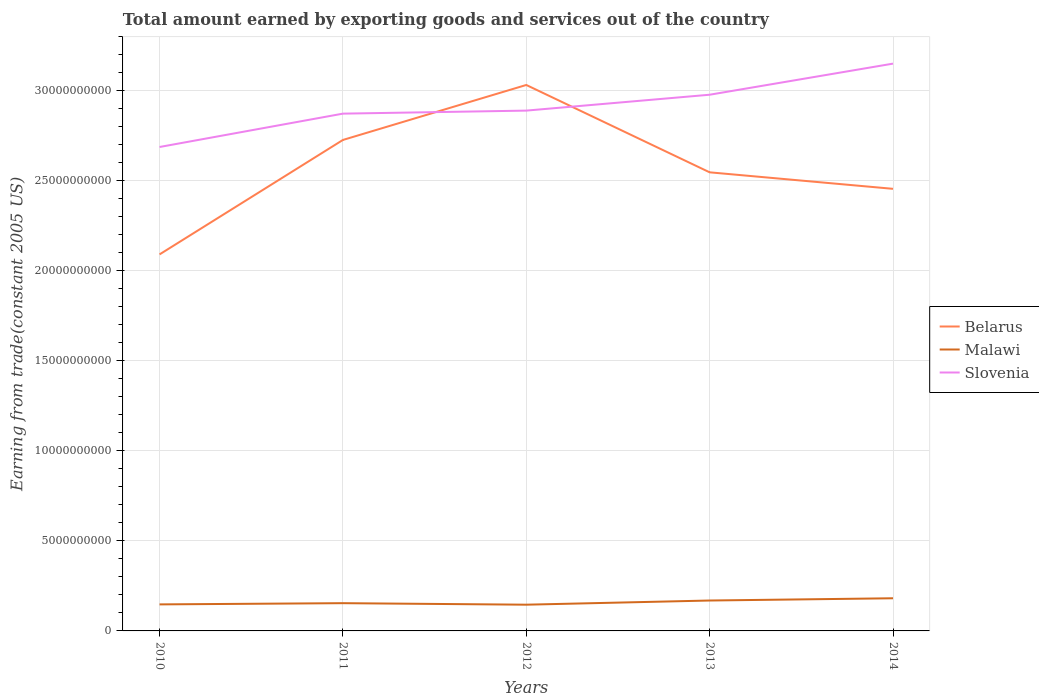How many different coloured lines are there?
Keep it short and to the point. 3. Does the line corresponding to Slovenia intersect with the line corresponding to Malawi?
Your answer should be very brief. No. Is the number of lines equal to the number of legend labels?
Your answer should be compact. Yes. Across all years, what is the maximum total amount earned by exporting goods and services in Belarus?
Ensure brevity in your answer.  2.09e+1. What is the total total amount earned by exporting goods and services in Slovenia in the graph?
Provide a short and direct response. -2.61e+09. What is the difference between the highest and the second highest total amount earned by exporting goods and services in Malawi?
Ensure brevity in your answer.  3.57e+08. How many years are there in the graph?
Offer a very short reply. 5. What is the difference between two consecutive major ticks on the Y-axis?
Offer a very short reply. 5.00e+09. Are the values on the major ticks of Y-axis written in scientific E-notation?
Keep it short and to the point. No. Where does the legend appear in the graph?
Make the answer very short. Center right. How many legend labels are there?
Offer a terse response. 3. What is the title of the graph?
Provide a succinct answer. Total amount earned by exporting goods and services out of the country. What is the label or title of the Y-axis?
Ensure brevity in your answer.  Earning from trade(constant 2005 US). What is the Earning from trade(constant 2005 US) in Belarus in 2010?
Your answer should be compact. 2.09e+1. What is the Earning from trade(constant 2005 US) in Malawi in 2010?
Give a very brief answer. 1.47e+09. What is the Earning from trade(constant 2005 US) of Slovenia in 2010?
Offer a terse response. 2.69e+1. What is the Earning from trade(constant 2005 US) of Belarus in 2011?
Provide a succinct answer. 2.73e+1. What is the Earning from trade(constant 2005 US) in Malawi in 2011?
Your answer should be compact. 1.54e+09. What is the Earning from trade(constant 2005 US) in Slovenia in 2011?
Provide a short and direct response. 2.87e+1. What is the Earning from trade(constant 2005 US) in Belarus in 2012?
Provide a succinct answer. 3.03e+1. What is the Earning from trade(constant 2005 US) in Malawi in 2012?
Your answer should be compact. 1.46e+09. What is the Earning from trade(constant 2005 US) of Slovenia in 2012?
Provide a short and direct response. 2.89e+1. What is the Earning from trade(constant 2005 US) in Belarus in 2013?
Your response must be concise. 2.55e+1. What is the Earning from trade(constant 2005 US) of Malawi in 2013?
Your response must be concise. 1.69e+09. What is the Earning from trade(constant 2005 US) of Slovenia in 2013?
Give a very brief answer. 2.98e+1. What is the Earning from trade(constant 2005 US) of Belarus in 2014?
Your response must be concise. 2.46e+1. What is the Earning from trade(constant 2005 US) in Malawi in 2014?
Make the answer very short. 1.81e+09. What is the Earning from trade(constant 2005 US) of Slovenia in 2014?
Offer a terse response. 3.15e+1. Across all years, what is the maximum Earning from trade(constant 2005 US) of Belarus?
Your response must be concise. 3.03e+1. Across all years, what is the maximum Earning from trade(constant 2005 US) of Malawi?
Keep it short and to the point. 1.81e+09. Across all years, what is the maximum Earning from trade(constant 2005 US) in Slovenia?
Ensure brevity in your answer.  3.15e+1. Across all years, what is the minimum Earning from trade(constant 2005 US) of Belarus?
Provide a short and direct response. 2.09e+1. Across all years, what is the minimum Earning from trade(constant 2005 US) in Malawi?
Your answer should be compact. 1.46e+09. Across all years, what is the minimum Earning from trade(constant 2005 US) in Slovenia?
Provide a short and direct response. 2.69e+1. What is the total Earning from trade(constant 2005 US) of Belarus in the graph?
Provide a short and direct response. 1.29e+11. What is the total Earning from trade(constant 2005 US) in Malawi in the graph?
Offer a very short reply. 7.97e+09. What is the total Earning from trade(constant 2005 US) of Slovenia in the graph?
Offer a very short reply. 1.46e+11. What is the difference between the Earning from trade(constant 2005 US) in Belarus in 2010 and that in 2011?
Provide a succinct answer. -6.36e+09. What is the difference between the Earning from trade(constant 2005 US) of Malawi in 2010 and that in 2011?
Offer a terse response. -6.82e+07. What is the difference between the Earning from trade(constant 2005 US) in Slovenia in 2010 and that in 2011?
Provide a short and direct response. -1.85e+09. What is the difference between the Earning from trade(constant 2005 US) of Belarus in 2010 and that in 2012?
Keep it short and to the point. -9.41e+09. What is the difference between the Earning from trade(constant 2005 US) in Malawi in 2010 and that in 2012?
Provide a short and direct response. 1.64e+07. What is the difference between the Earning from trade(constant 2005 US) of Slovenia in 2010 and that in 2012?
Your answer should be very brief. -2.02e+09. What is the difference between the Earning from trade(constant 2005 US) in Belarus in 2010 and that in 2013?
Keep it short and to the point. -4.56e+09. What is the difference between the Earning from trade(constant 2005 US) of Malawi in 2010 and that in 2013?
Offer a very short reply. -2.16e+08. What is the difference between the Earning from trade(constant 2005 US) in Slovenia in 2010 and that in 2013?
Give a very brief answer. -2.90e+09. What is the difference between the Earning from trade(constant 2005 US) of Belarus in 2010 and that in 2014?
Offer a very short reply. -3.64e+09. What is the difference between the Earning from trade(constant 2005 US) of Malawi in 2010 and that in 2014?
Provide a short and direct response. -3.41e+08. What is the difference between the Earning from trade(constant 2005 US) in Slovenia in 2010 and that in 2014?
Give a very brief answer. -4.63e+09. What is the difference between the Earning from trade(constant 2005 US) of Belarus in 2011 and that in 2012?
Ensure brevity in your answer.  -3.05e+09. What is the difference between the Earning from trade(constant 2005 US) of Malawi in 2011 and that in 2012?
Your answer should be very brief. 8.46e+07. What is the difference between the Earning from trade(constant 2005 US) of Slovenia in 2011 and that in 2012?
Your answer should be very brief. -1.68e+08. What is the difference between the Earning from trade(constant 2005 US) in Belarus in 2011 and that in 2013?
Provide a succinct answer. 1.80e+09. What is the difference between the Earning from trade(constant 2005 US) in Malawi in 2011 and that in 2013?
Offer a very short reply. -1.48e+08. What is the difference between the Earning from trade(constant 2005 US) in Slovenia in 2011 and that in 2013?
Provide a succinct answer. -1.05e+09. What is the difference between the Earning from trade(constant 2005 US) in Belarus in 2011 and that in 2014?
Provide a short and direct response. 2.71e+09. What is the difference between the Earning from trade(constant 2005 US) in Malawi in 2011 and that in 2014?
Offer a terse response. -2.72e+08. What is the difference between the Earning from trade(constant 2005 US) of Slovenia in 2011 and that in 2014?
Your answer should be compact. -2.78e+09. What is the difference between the Earning from trade(constant 2005 US) in Belarus in 2012 and that in 2013?
Provide a short and direct response. 4.85e+09. What is the difference between the Earning from trade(constant 2005 US) in Malawi in 2012 and that in 2013?
Offer a very short reply. -2.32e+08. What is the difference between the Earning from trade(constant 2005 US) in Slovenia in 2012 and that in 2013?
Your answer should be compact. -8.82e+08. What is the difference between the Earning from trade(constant 2005 US) of Belarus in 2012 and that in 2014?
Your answer should be very brief. 5.77e+09. What is the difference between the Earning from trade(constant 2005 US) in Malawi in 2012 and that in 2014?
Your answer should be compact. -3.57e+08. What is the difference between the Earning from trade(constant 2005 US) of Slovenia in 2012 and that in 2014?
Your answer should be very brief. -2.61e+09. What is the difference between the Earning from trade(constant 2005 US) in Belarus in 2013 and that in 2014?
Provide a short and direct response. 9.17e+08. What is the difference between the Earning from trade(constant 2005 US) of Malawi in 2013 and that in 2014?
Offer a terse response. -1.25e+08. What is the difference between the Earning from trade(constant 2005 US) of Slovenia in 2013 and that in 2014?
Your answer should be very brief. -1.73e+09. What is the difference between the Earning from trade(constant 2005 US) in Belarus in 2010 and the Earning from trade(constant 2005 US) in Malawi in 2011?
Provide a short and direct response. 1.94e+1. What is the difference between the Earning from trade(constant 2005 US) of Belarus in 2010 and the Earning from trade(constant 2005 US) of Slovenia in 2011?
Offer a very short reply. -7.82e+09. What is the difference between the Earning from trade(constant 2005 US) in Malawi in 2010 and the Earning from trade(constant 2005 US) in Slovenia in 2011?
Offer a very short reply. -2.73e+1. What is the difference between the Earning from trade(constant 2005 US) in Belarus in 2010 and the Earning from trade(constant 2005 US) in Malawi in 2012?
Offer a very short reply. 1.95e+1. What is the difference between the Earning from trade(constant 2005 US) of Belarus in 2010 and the Earning from trade(constant 2005 US) of Slovenia in 2012?
Offer a very short reply. -7.99e+09. What is the difference between the Earning from trade(constant 2005 US) of Malawi in 2010 and the Earning from trade(constant 2005 US) of Slovenia in 2012?
Keep it short and to the point. -2.74e+1. What is the difference between the Earning from trade(constant 2005 US) in Belarus in 2010 and the Earning from trade(constant 2005 US) in Malawi in 2013?
Provide a short and direct response. 1.92e+1. What is the difference between the Earning from trade(constant 2005 US) in Belarus in 2010 and the Earning from trade(constant 2005 US) in Slovenia in 2013?
Give a very brief answer. -8.87e+09. What is the difference between the Earning from trade(constant 2005 US) in Malawi in 2010 and the Earning from trade(constant 2005 US) in Slovenia in 2013?
Give a very brief answer. -2.83e+1. What is the difference between the Earning from trade(constant 2005 US) of Belarus in 2010 and the Earning from trade(constant 2005 US) of Malawi in 2014?
Your response must be concise. 1.91e+1. What is the difference between the Earning from trade(constant 2005 US) in Belarus in 2010 and the Earning from trade(constant 2005 US) in Slovenia in 2014?
Your response must be concise. -1.06e+1. What is the difference between the Earning from trade(constant 2005 US) of Malawi in 2010 and the Earning from trade(constant 2005 US) of Slovenia in 2014?
Your response must be concise. -3.00e+1. What is the difference between the Earning from trade(constant 2005 US) of Belarus in 2011 and the Earning from trade(constant 2005 US) of Malawi in 2012?
Provide a succinct answer. 2.58e+1. What is the difference between the Earning from trade(constant 2005 US) in Belarus in 2011 and the Earning from trade(constant 2005 US) in Slovenia in 2012?
Keep it short and to the point. -1.63e+09. What is the difference between the Earning from trade(constant 2005 US) of Malawi in 2011 and the Earning from trade(constant 2005 US) of Slovenia in 2012?
Make the answer very short. -2.74e+1. What is the difference between the Earning from trade(constant 2005 US) in Belarus in 2011 and the Earning from trade(constant 2005 US) in Malawi in 2013?
Your response must be concise. 2.56e+1. What is the difference between the Earning from trade(constant 2005 US) in Belarus in 2011 and the Earning from trade(constant 2005 US) in Slovenia in 2013?
Keep it short and to the point. -2.51e+09. What is the difference between the Earning from trade(constant 2005 US) in Malawi in 2011 and the Earning from trade(constant 2005 US) in Slovenia in 2013?
Keep it short and to the point. -2.82e+1. What is the difference between the Earning from trade(constant 2005 US) in Belarus in 2011 and the Earning from trade(constant 2005 US) in Malawi in 2014?
Ensure brevity in your answer.  2.55e+1. What is the difference between the Earning from trade(constant 2005 US) of Belarus in 2011 and the Earning from trade(constant 2005 US) of Slovenia in 2014?
Ensure brevity in your answer.  -4.24e+09. What is the difference between the Earning from trade(constant 2005 US) of Malawi in 2011 and the Earning from trade(constant 2005 US) of Slovenia in 2014?
Provide a short and direct response. -3.00e+1. What is the difference between the Earning from trade(constant 2005 US) in Belarus in 2012 and the Earning from trade(constant 2005 US) in Malawi in 2013?
Provide a short and direct response. 2.86e+1. What is the difference between the Earning from trade(constant 2005 US) in Belarus in 2012 and the Earning from trade(constant 2005 US) in Slovenia in 2013?
Offer a very short reply. 5.42e+08. What is the difference between the Earning from trade(constant 2005 US) of Malawi in 2012 and the Earning from trade(constant 2005 US) of Slovenia in 2013?
Provide a short and direct response. -2.83e+1. What is the difference between the Earning from trade(constant 2005 US) in Belarus in 2012 and the Earning from trade(constant 2005 US) in Malawi in 2014?
Make the answer very short. 2.85e+1. What is the difference between the Earning from trade(constant 2005 US) in Belarus in 2012 and the Earning from trade(constant 2005 US) in Slovenia in 2014?
Offer a very short reply. -1.18e+09. What is the difference between the Earning from trade(constant 2005 US) of Malawi in 2012 and the Earning from trade(constant 2005 US) of Slovenia in 2014?
Offer a terse response. -3.00e+1. What is the difference between the Earning from trade(constant 2005 US) in Belarus in 2013 and the Earning from trade(constant 2005 US) in Malawi in 2014?
Keep it short and to the point. 2.37e+1. What is the difference between the Earning from trade(constant 2005 US) of Belarus in 2013 and the Earning from trade(constant 2005 US) of Slovenia in 2014?
Your answer should be compact. -6.04e+09. What is the difference between the Earning from trade(constant 2005 US) of Malawi in 2013 and the Earning from trade(constant 2005 US) of Slovenia in 2014?
Provide a short and direct response. -2.98e+1. What is the average Earning from trade(constant 2005 US) in Belarus per year?
Offer a terse response. 2.57e+1. What is the average Earning from trade(constant 2005 US) in Malawi per year?
Your response must be concise. 1.59e+09. What is the average Earning from trade(constant 2005 US) in Slovenia per year?
Offer a terse response. 2.92e+1. In the year 2010, what is the difference between the Earning from trade(constant 2005 US) of Belarus and Earning from trade(constant 2005 US) of Malawi?
Offer a very short reply. 1.94e+1. In the year 2010, what is the difference between the Earning from trade(constant 2005 US) of Belarus and Earning from trade(constant 2005 US) of Slovenia?
Make the answer very short. -5.96e+09. In the year 2010, what is the difference between the Earning from trade(constant 2005 US) in Malawi and Earning from trade(constant 2005 US) in Slovenia?
Your response must be concise. -2.54e+1. In the year 2011, what is the difference between the Earning from trade(constant 2005 US) in Belarus and Earning from trade(constant 2005 US) in Malawi?
Ensure brevity in your answer.  2.57e+1. In the year 2011, what is the difference between the Earning from trade(constant 2005 US) in Belarus and Earning from trade(constant 2005 US) in Slovenia?
Make the answer very short. -1.46e+09. In the year 2011, what is the difference between the Earning from trade(constant 2005 US) in Malawi and Earning from trade(constant 2005 US) in Slovenia?
Keep it short and to the point. -2.72e+1. In the year 2012, what is the difference between the Earning from trade(constant 2005 US) of Belarus and Earning from trade(constant 2005 US) of Malawi?
Your answer should be very brief. 2.89e+1. In the year 2012, what is the difference between the Earning from trade(constant 2005 US) in Belarus and Earning from trade(constant 2005 US) in Slovenia?
Keep it short and to the point. 1.42e+09. In the year 2012, what is the difference between the Earning from trade(constant 2005 US) of Malawi and Earning from trade(constant 2005 US) of Slovenia?
Offer a very short reply. -2.74e+1. In the year 2013, what is the difference between the Earning from trade(constant 2005 US) in Belarus and Earning from trade(constant 2005 US) in Malawi?
Offer a very short reply. 2.38e+1. In the year 2013, what is the difference between the Earning from trade(constant 2005 US) of Belarus and Earning from trade(constant 2005 US) of Slovenia?
Your response must be concise. -4.31e+09. In the year 2013, what is the difference between the Earning from trade(constant 2005 US) in Malawi and Earning from trade(constant 2005 US) in Slovenia?
Keep it short and to the point. -2.81e+1. In the year 2014, what is the difference between the Earning from trade(constant 2005 US) in Belarus and Earning from trade(constant 2005 US) in Malawi?
Your answer should be compact. 2.27e+1. In the year 2014, what is the difference between the Earning from trade(constant 2005 US) in Belarus and Earning from trade(constant 2005 US) in Slovenia?
Offer a terse response. -6.95e+09. In the year 2014, what is the difference between the Earning from trade(constant 2005 US) of Malawi and Earning from trade(constant 2005 US) of Slovenia?
Your answer should be very brief. -2.97e+1. What is the ratio of the Earning from trade(constant 2005 US) of Belarus in 2010 to that in 2011?
Your answer should be compact. 0.77. What is the ratio of the Earning from trade(constant 2005 US) in Malawi in 2010 to that in 2011?
Your response must be concise. 0.96. What is the ratio of the Earning from trade(constant 2005 US) in Slovenia in 2010 to that in 2011?
Your response must be concise. 0.94. What is the ratio of the Earning from trade(constant 2005 US) of Belarus in 2010 to that in 2012?
Keep it short and to the point. 0.69. What is the ratio of the Earning from trade(constant 2005 US) in Malawi in 2010 to that in 2012?
Your answer should be compact. 1.01. What is the ratio of the Earning from trade(constant 2005 US) in Slovenia in 2010 to that in 2012?
Give a very brief answer. 0.93. What is the ratio of the Earning from trade(constant 2005 US) of Belarus in 2010 to that in 2013?
Your answer should be very brief. 0.82. What is the ratio of the Earning from trade(constant 2005 US) in Malawi in 2010 to that in 2013?
Offer a terse response. 0.87. What is the ratio of the Earning from trade(constant 2005 US) in Slovenia in 2010 to that in 2013?
Make the answer very short. 0.9. What is the ratio of the Earning from trade(constant 2005 US) in Belarus in 2010 to that in 2014?
Keep it short and to the point. 0.85. What is the ratio of the Earning from trade(constant 2005 US) in Malawi in 2010 to that in 2014?
Offer a very short reply. 0.81. What is the ratio of the Earning from trade(constant 2005 US) in Slovenia in 2010 to that in 2014?
Your response must be concise. 0.85. What is the ratio of the Earning from trade(constant 2005 US) of Belarus in 2011 to that in 2012?
Give a very brief answer. 0.9. What is the ratio of the Earning from trade(constant 2005 US) in Malawi in 2011 to that in 2012?
Ensure brevity in your answer.  1.06. What is the ratio of the Earning from trade(constant 2005 US) of Belarus in 2011 to that in 2013?
Make the answer very short. 1.07. What is the ratio of the Earning from trade(constant 2005 US) of Malawi in 2011 to that in 2013?
Offer a terse response. 0.91. What is the ratio of the Earning from trade(constant 2005 US) of Slovenia in 2011 to that in 2013?
Give a very brief answer. 0.96. What is the ratio of the Earning from trade(constant 2005 US) of Belarus in 2011 to that in 2014?
Provide a succinct answer. 1.11. What is the ratio of the Earning from trade(constant 2005 US) of Malawi in 2011 to that in 2014?
Your answer should be compact. 0.85. What is the ratio of the Earning from trade(constant 2005 US) of Slovenia in 2011 to that in 2014?
Ensure brevity in your answer.  0.91. What is the ratio of the Earning from trade(constant 2005 US) in Belarus in 2012 to that in 2013?
Your answer should be very brief. 1.19. What is the ratio of the Earning from trade(constant 2005 US) in Malawi in 2012 to that in 2013?
Your response must be concise. 0.86. What is the ratio of the Earning from trade(constant 2005 US) in Slovenia in 2012 to that in 2013?
Your answer should be compact. 0.97. What is the ratio of the Earning from trade(constant 2005 US) of Belarus in 2012 to that in 2014?
Provide a short and direct response. 1.23. What is the ratio of the Earning from trade(constant 2005 US) of Malawi in 2012 to that in 2014?
Keep it short and to the point. 0.8. What is the ratio of the Earning from trade(constant 2005 US) in Slovenia in 2012 to that in 2014?
Provide a short and direct response. 0.92. What is the ratio of the Earning from trade(constant 2005 US) in Belarus in 2013 to that in 2014?
Offer a very short reply. 1.04. What is the ratio of the Earning from trade(constant 2005 US) in Malawi in 2013 to that in 2014?
Your answer should be compact. 0.93. What is the ratio of the Earning from trade(constant 2005 US) in Slovenia in 2013 to that in 2014?
Keep it short and to the point. 0.95. What is the difference between the highest and the second highest Earning from trade(constant 2005 US) in Belarus?
Your response must be concise. 3.05e+09. What is the difference between the highest and the second highest Earning from trade(constant 2005 US) in Malawi?
Provide a succinct answer. 1.25e+08. What is the difference between the highest and the second highest Earning from trade(constant 2005 US) of Slovenia?
Your answer should be compact. 1.73e+09. What is the difference between the highest and the lowest Earning from trade(constant 2005 US) in Belarus?
Your answer should be very brief. 9.41e+09. What is the difference between the highest and the lowest Earning from trade(constant 2005 US) in Malawi?
Give a very brief answer. 3.57e+08. What is the difference between the highest and the lowest Earning from trade(constant 2005 US) of Slovenia?
Offer a very short reply. 4.63e+09. 